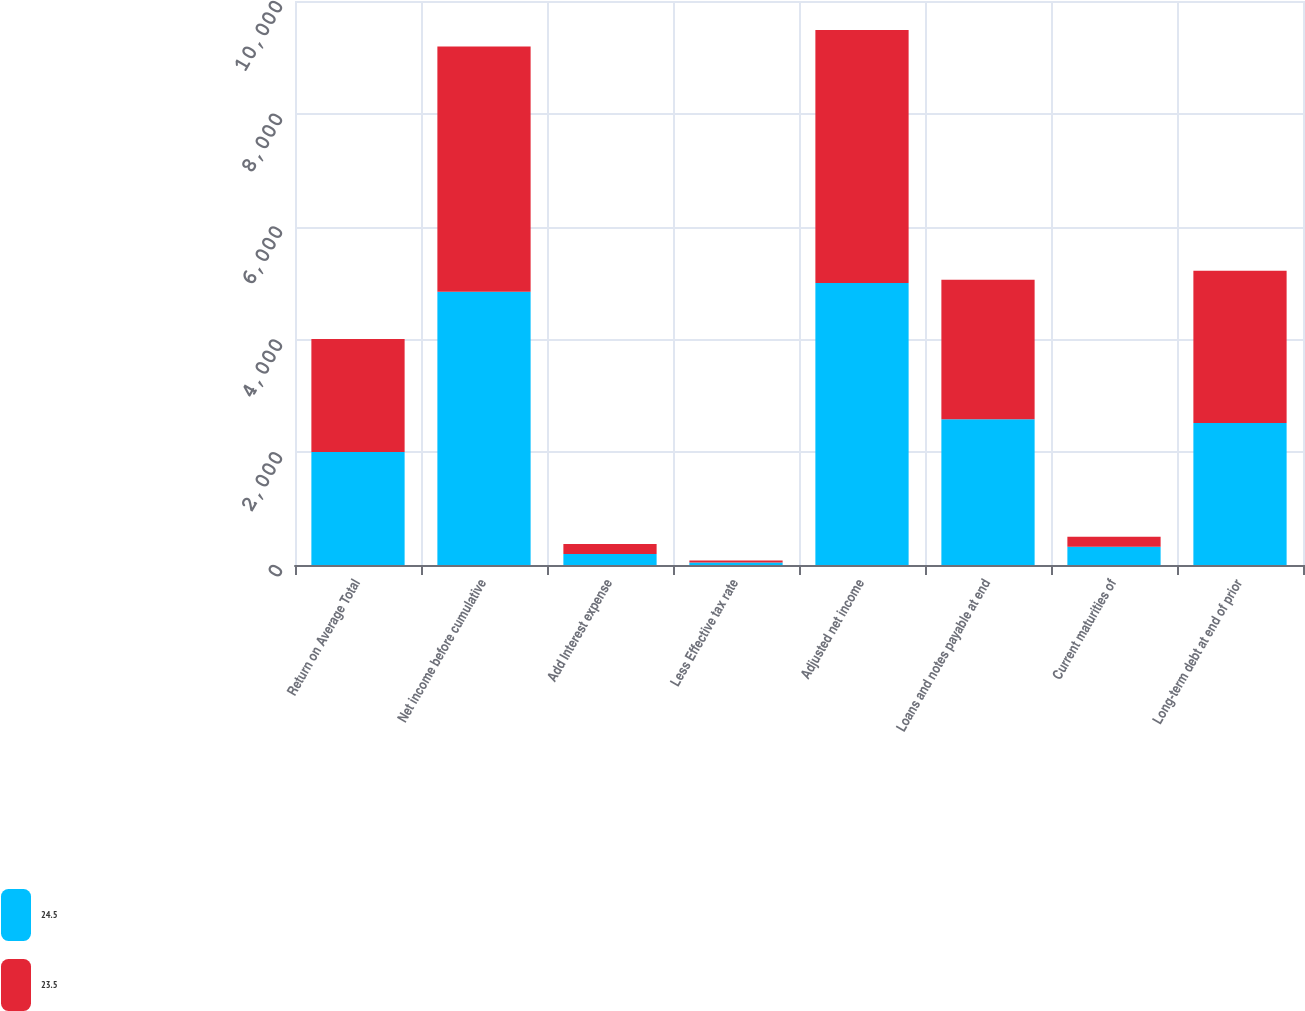<chart> <loc_0><loc_0><loc_500><loc_500><stacked_bar_chart><ecel><fcel>Return on Average Total<fcel>Net income before cumulative<fcel>Add Interest expense<fcel>Less Effective tax rate<fcel>Adjusted net income<fcel>Loans and notes payable at end<fcel>Current maturities of<fcel>Long-term debt at end of prior<nl><fcel>24.5<fcel>2004<fcel>4847<fcel>196<fcel>43<fcel>5000<fcel>2583<fcel>323<fcel>2517<nl><fcel>23.5<fcel>2003<fcel>4347<fcel>178<fcel>37<fcel>4488<fcel>2475<fcel>180<fcel>2701<nl></chart> 